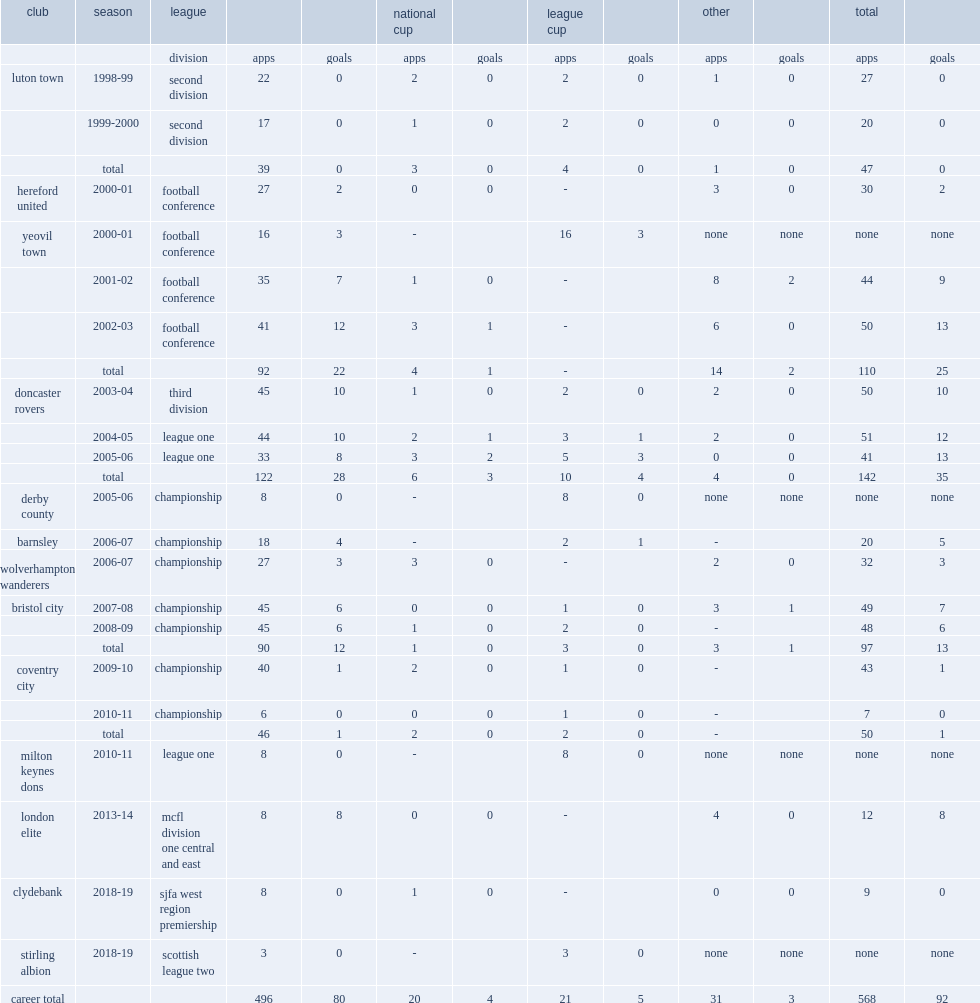How many appearances did mcindoe make for the doncaster rovers? 142.0. 